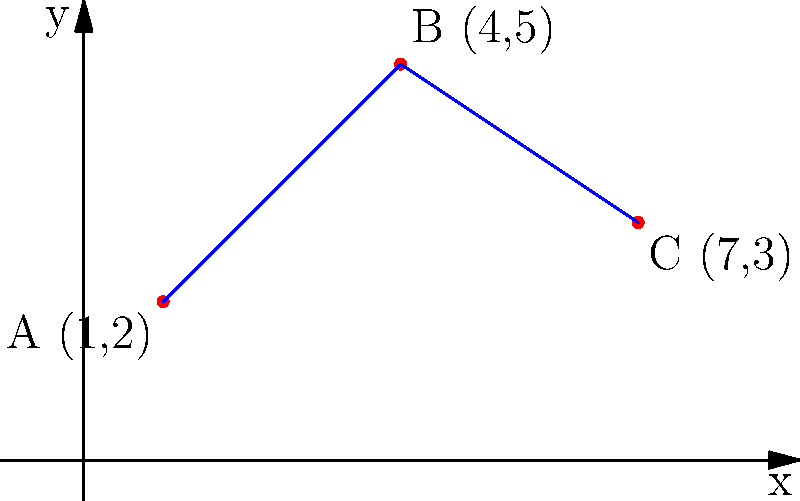A local bakery is planning to use drone delivery for three of its regular customers. The bakery's location is at the origin (0,0), and the customers' locations are plotted on a 2D coordinate system as shown: A(1,2), B(4,5), and C(7,3). If the drone follows a route from the bakery to A, then to B, and finally to C, what is the total distance traveled by the drone? (Round your answer to the nearest whole number.) Let's break this down step-by-step:

1. First, we need to calculate the distance from the origin (0,0) to point A(1,2):
   Distance = $\sqrt{(1-0)^2 + (2-0)^2} = \sqrt{1 + 4} = \sqrt{5}$

2. Next, we calculate the distance from A(1,2) to B(4,5):
   Distance = $\sqrt{(4-1)^2 + (5-2)^2} = \sqrt{9 + 9} = \sqrt{18} = 3\sqrt{2}$

3. Finally, we calculate the distance from B(4,5) to C(7,3):
   Distance = $\sqrt{(7-4)^2 + (3-5)^2} = \sqrt{9 + 4} = \sqrt{13}$

4. Now, we sum up all these distances:
   Total distance = $\sqrt{5} + 3\sqrt{2} + \sqrt{13}$

5. Using a calculator to approximate:
   $\sqrt{5} \approx 2.24$
   $3\sqrt{2} \approx 4.24$
   $\sqrt{13} \approx 3.61$

6. Adding these up:
   2.24 + 4.24 + 3.61 = 10.09

7. Rounding to the nearest whole number:
   10.09 ≈ 10

Therefore, the total distance traveled by the drone is approximately 10 units.
Answer: 10 units 